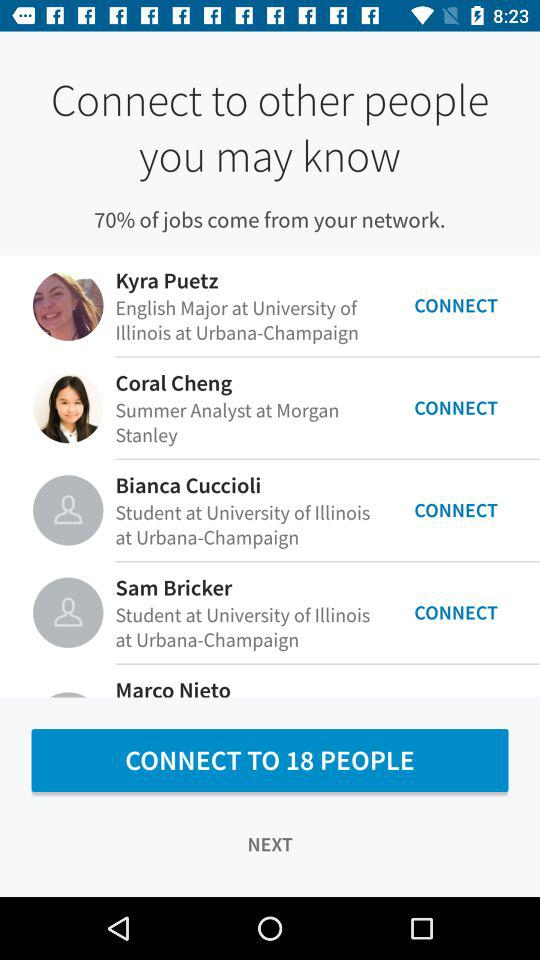From which university is Kyra Puetz? Kyra Puetz is from the "University of Illinois at Urbana-Champaign". 